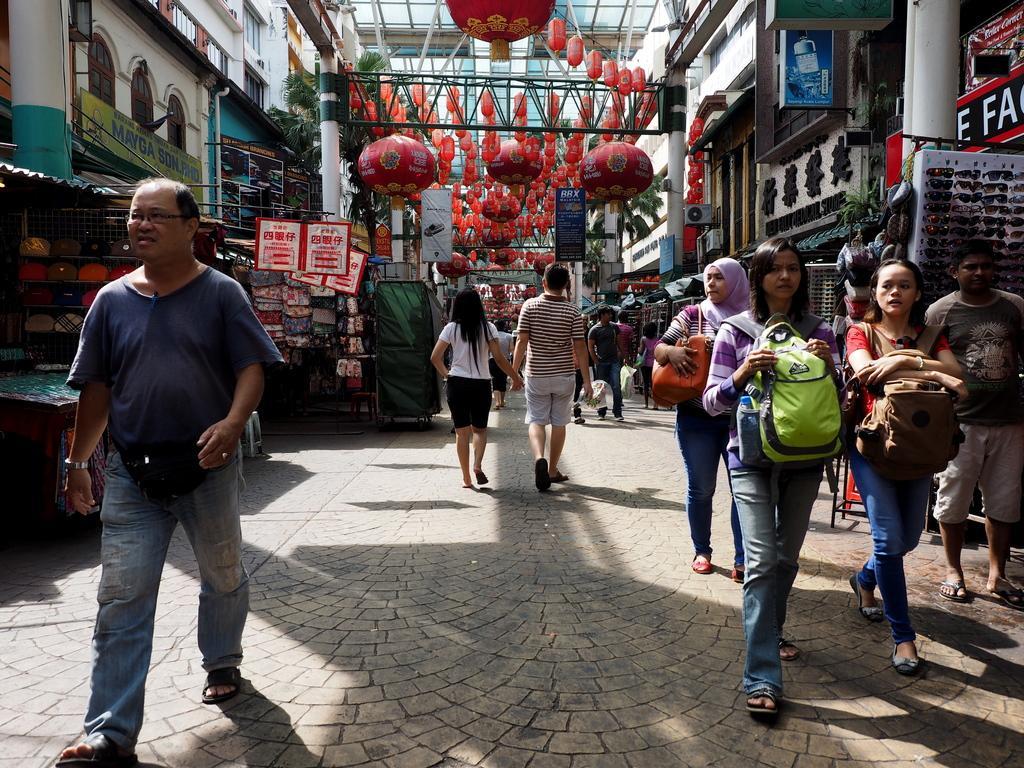Describe this image in one or two sentences. There are groups of people walking. These are the lanterns, which are hanging to the roof. I can see the buildings. This looks like a pillar. These are the goggles, which are arranged in an order. This is a name board, which is attached to the wall. These are the shops. This looks like a market. I can see a tree. 